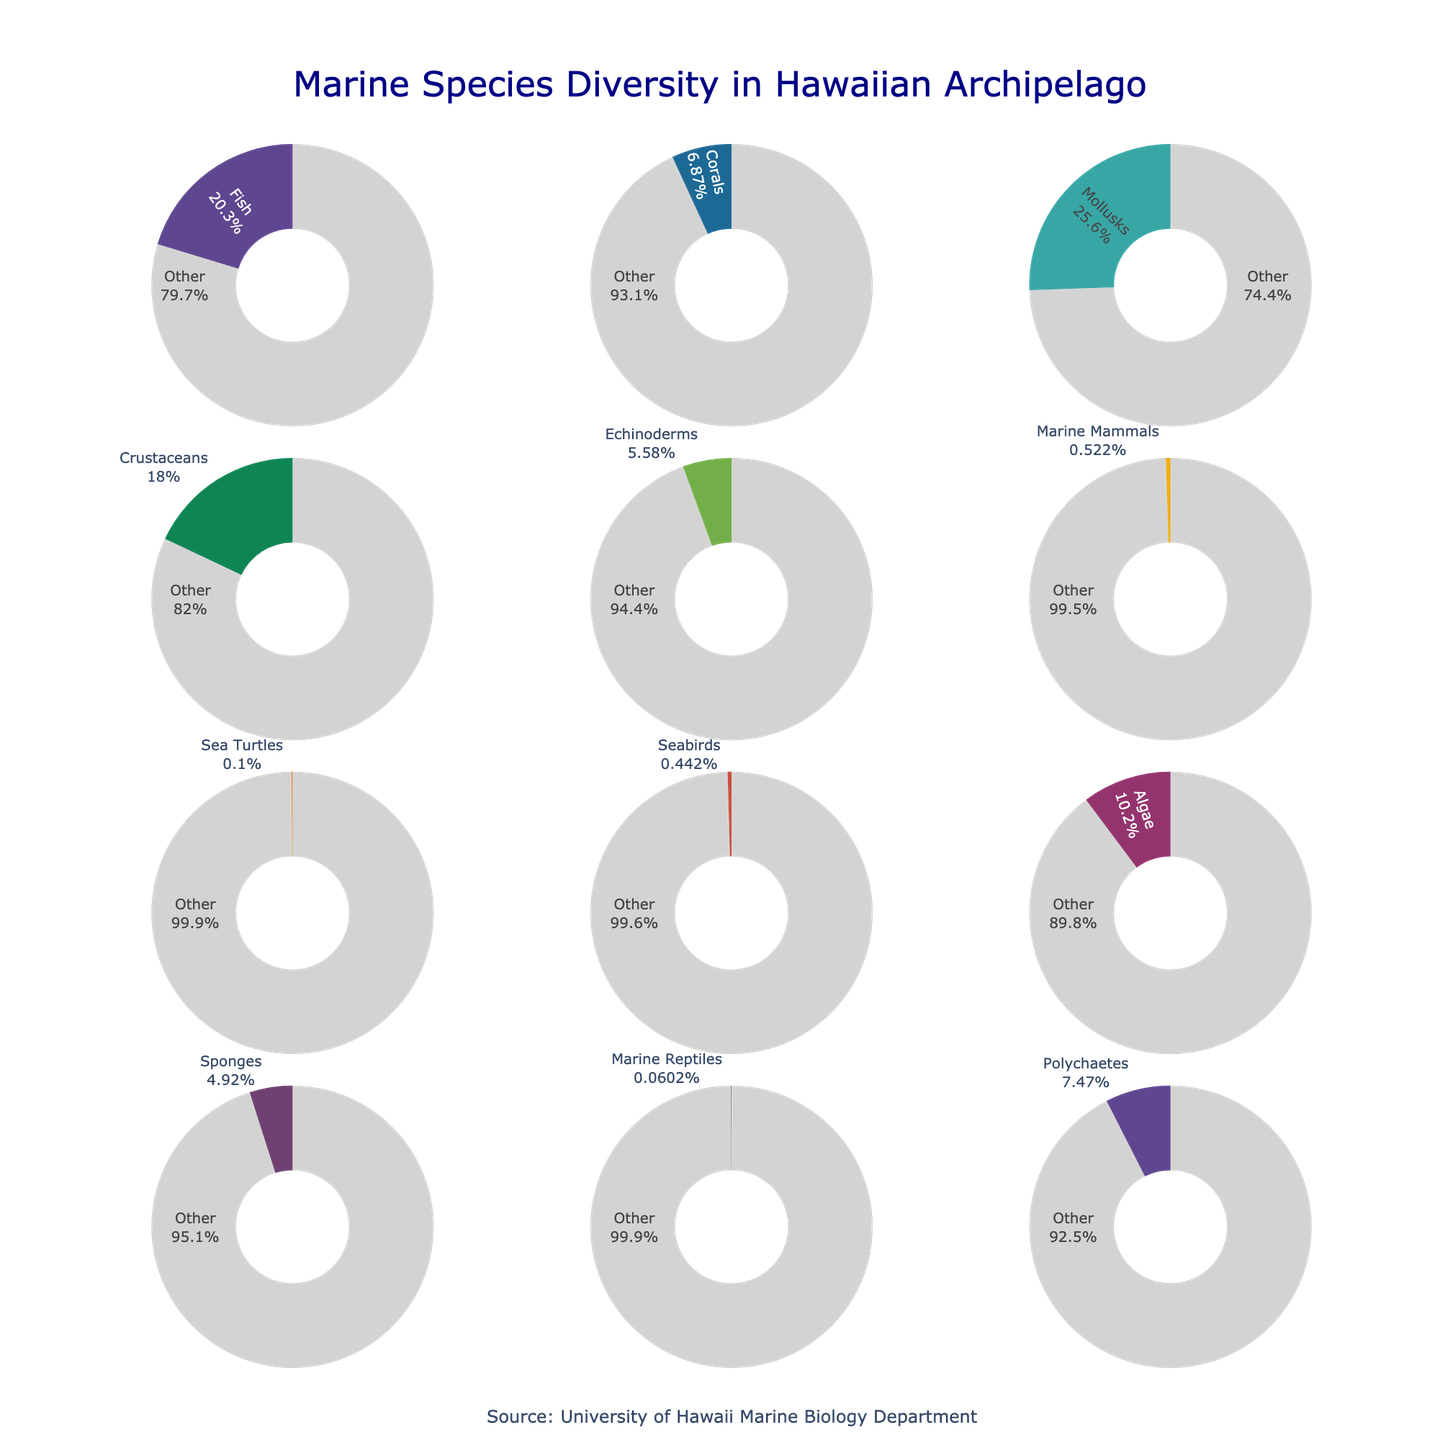Which taxonomic group has the highest species count? The figure shows various pie charts representing different taxonomic groups and their species counts. By identifying the pie chart with the largest proportion of its specific color, we see that Mollusks have the highest species count.
Answer: Mollusks What percentage of the total species does the Fish taxonomic group represent? The percentage of Fish can be found in its pie chart by looking at its proportion. The slice labeled 'Fish' must be examined for its percentage.
Answer: Approx. 24% What is the combined species count of Marine Mammals and Sea Turtles? We add the species count of Marine Mammals (26) to that of Sea Turtles (5). Summing these gives us a total species count.
Answer: 31 Which taxonomic group has the smallest species count, and what is that count? The pie charts show each group’s count. By identifying the smallest slice in terms of the count, Marine Reptiles is the group with the smallest count.
Answer: Marine Reptiles, 3 How does the species count of Algae compare to that of Polychaetes? We need to compare the slice labels for Algae and Polychaetes. Algae has 508 species, whereas Polychaetes has 372 species.
Answer: Algae has more species Between Corals and Sponges, which group has a higher percentage of the total species, and how much higher is it? By comparing their respective pie chart slices, Corals (342) have a higher species count than Sponges (245). Calculate their percentages of the total and find the difference.
Answer: Corals, Approx. 10% What is the total number of species represented in all the taxonomic groups combined? Summing up all the species counts given: 1011 (Fish) + 342 (Corals) + 1273 (Mollusks) + 895 (Crustaceans) + 278 (Echinoderms) + 26 (Marine Mammals) + 5 (Sea Turtles) + 22 (Seabirds) + 508 (Algae) + 245 (Sponges) + 3 (Marine Reptiles) + 372 (Polychaetes) equals 4980.
Answer: 4980 Which taxonomic group contributes approximately 26% of the total species count? By examining the pie charts and identifying the slice close to 26%, we find that Crustaceans correspond to this proportion, as 895 of 4980 is approximately 17.97%.
Answer: None fit exactly, but Crustaceans are closest How many taxonomic groups have a species count less than 1000? Count the number of groups from the visual that have their species count under 1000, looking at the species counts within each pie chart.
Answer: 10 What is the difference in species count between Echinoderms and Seabirds? Subtract the species count of Seabirds (22) from that of Echinoderms (278) to find the difference.
Answer: 256 